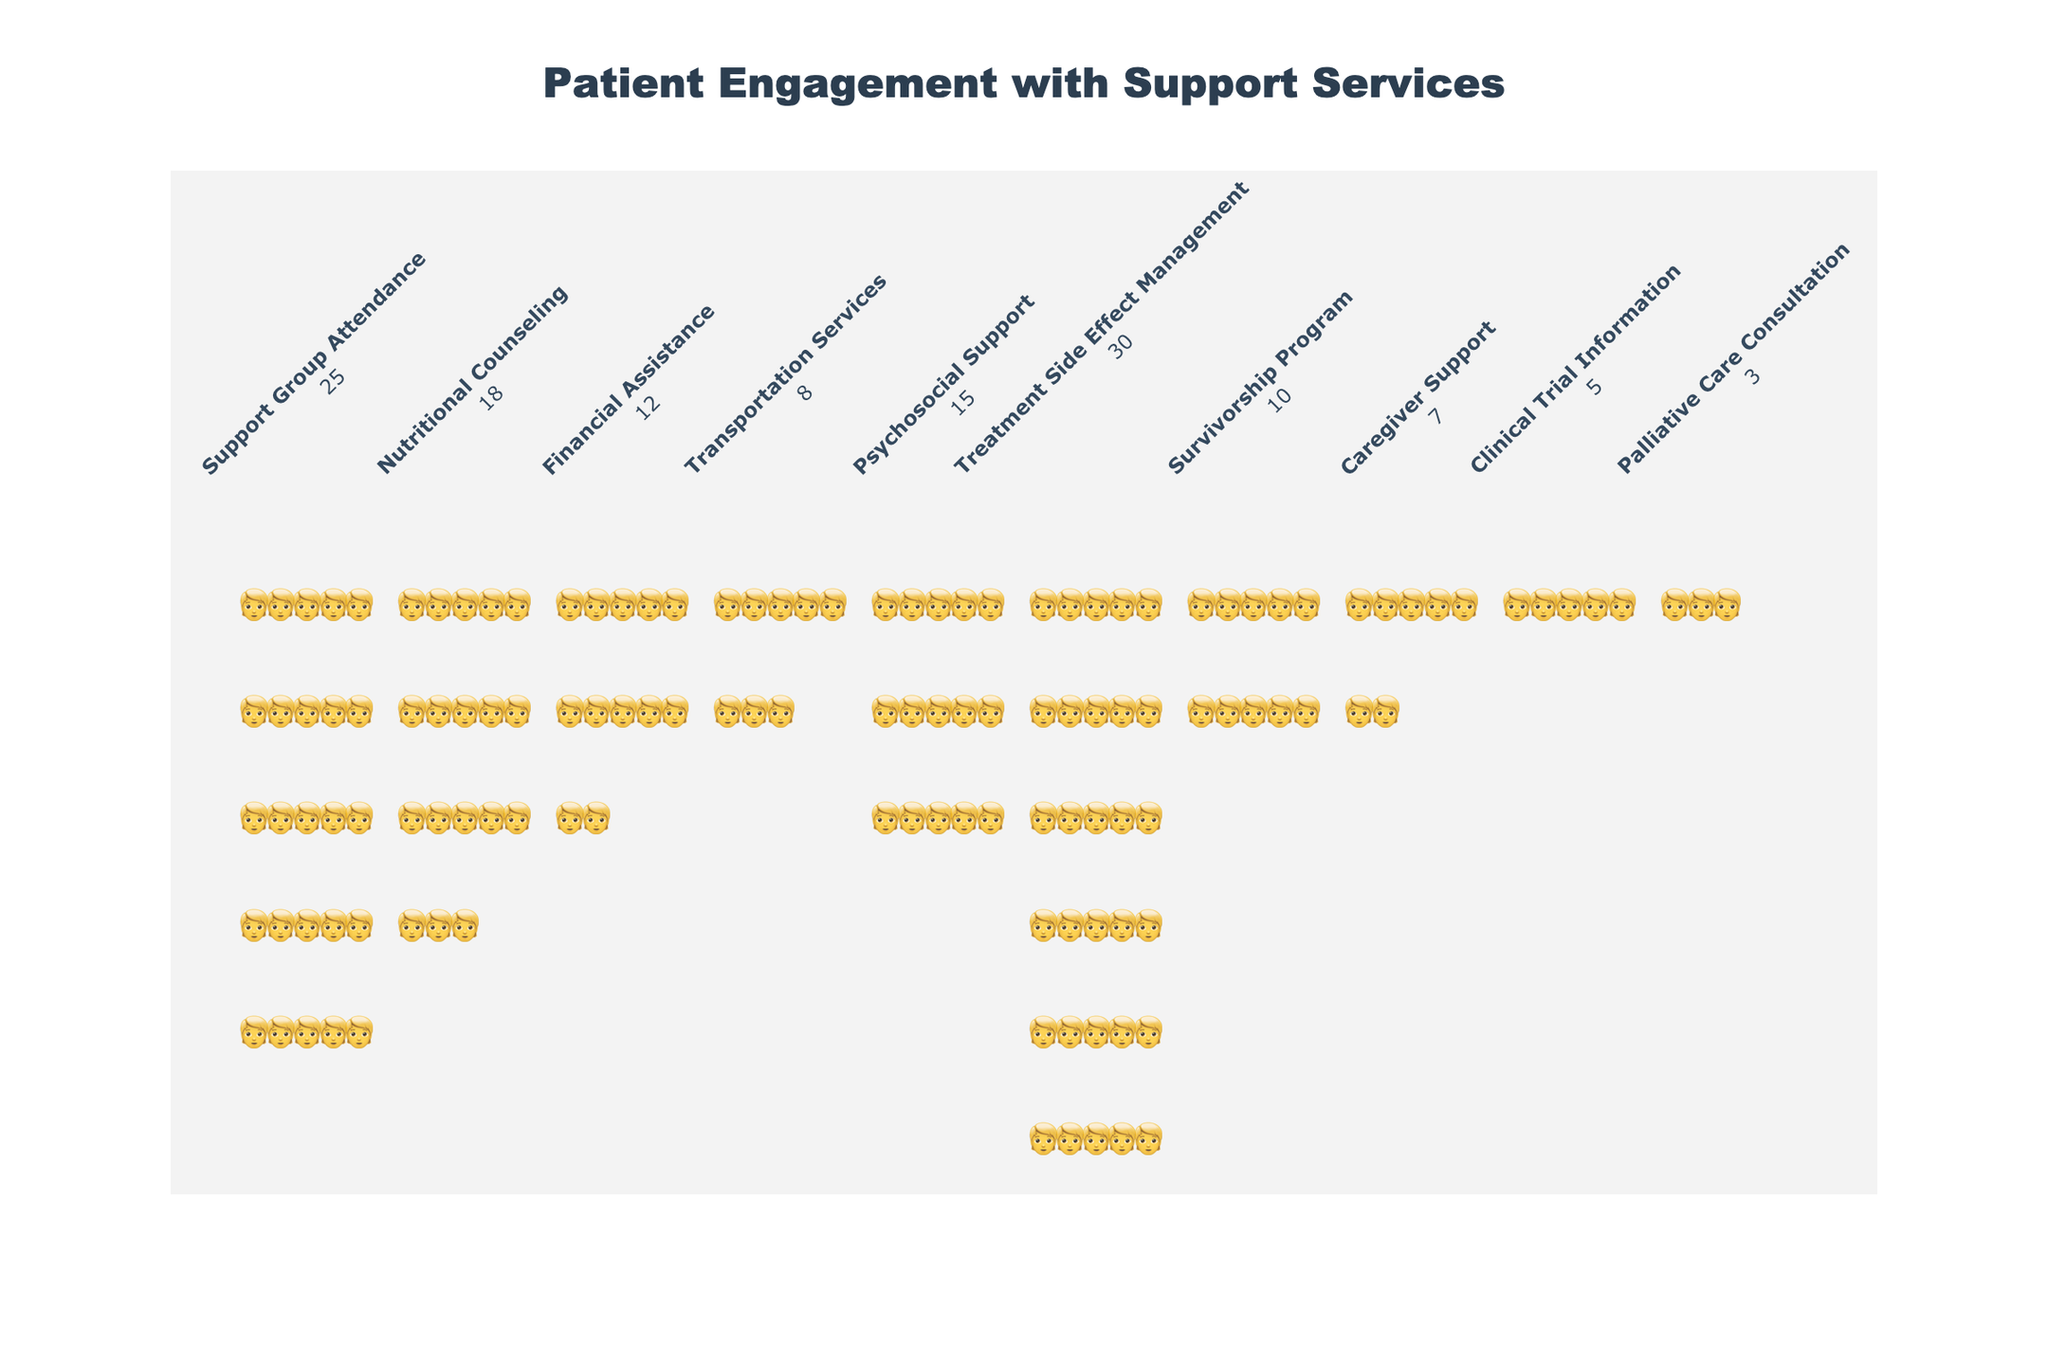what is the title of the figure? The title is centered at the top of the figure in a larger, bold font.
Answer: Patient Engagement with Support Services how many patients attended the support group? Each icon represents one patient, and there are 25 icons in the Support Group Attendance column.
Answer: 25 which service had the least patient engagement? The service corresponding to the fewest icons is Palliative Care Consultation with 3 icons.
Answer: Palliative Care Consultation what is the difference in the number of patients between Nutritional Counseling and Financial Assistance? Nutritional Counseling has 18 patients, and Financial Assistance has 12 patients. The difference is 18 - 12 = 6.
Answer: 6 what is the total number of patients engaged with Clinical Trial Information, Survivorship Program, and Caregiver Support combined? Adding up the patients: Clinical Trial Information (5) + Survivorship Program (10) + Caregiver Support (7) = 5 + 10 + 7 = 22.
Answer: 22 which service has the second highest number of patients? The service with the second highest number of patient icons is Treatment Side Effect Management with 30 patients, followed by Support Group Attendance with 25 patients.
Answer: Support Group Attendance are there more patients in Nutritional Counseling or Psychosocial Support? Nutritional Counseling has 18 patients, whereas Psychosocial Support has 15 patients. 18 is greater than 15.
Answer: Nutritional Counseling what is the average number of patients across all services? Summing up all patients: 25 + 18 + 12 + 8 + 15 + 30 + 10 + 7 + 5 + 3 = 133. There are 10 services. Average patients is 133 / 10 = 13.3.
Answer: 13.3 how many more patients are engaged in Treatment Side Effect Management compared to Palliative Care Consultation? Treatment Side Effect Management has 30 patients, while Palliative Care Consultation has 3. The difference is 30 - 3 = 27.
Answer: 27 